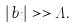<formula> <loc_0><loc_0><loc_500><loc_500>| b _ { i } | > > \Lambda .</formula> 